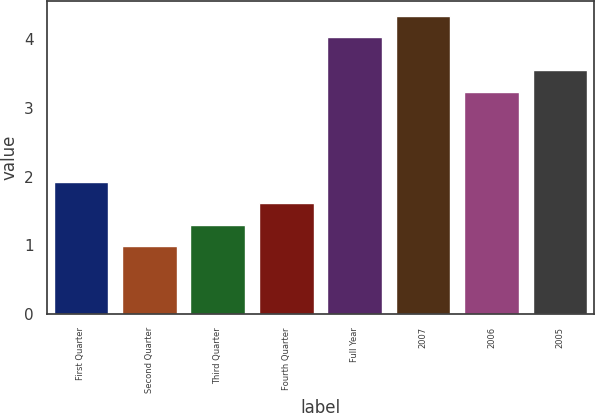Convert chart. <chart><loc_0><loc_0><loc_500><loc_500><bar_chart><fcel>First Quarter<fcel>Second Quarter<fcel>Third Quarter<fcel>Fourth Quarter<fcel>Full Year<fcel>2007<fcel>2006<fcel>2005<nl><fcel>1.92<fcel>0.99<fcel>1.3<fcel>1.61<fcel>4.03<fcel>4.34<fcel>3.24<fcel>3.55<nl></chart> 